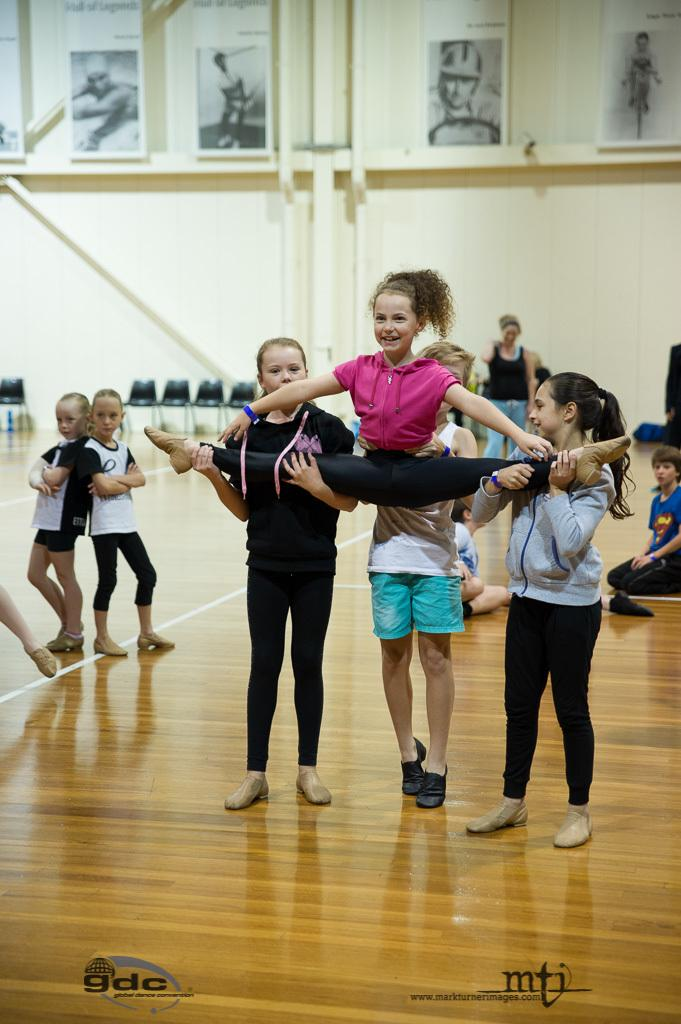What are the people in the image doing? There is a group of people on the floor in the image. What can be seen in the background of the image? There are chairs, a wall, and photo frames in the background of the image. What time of day was the image taken? The image was taken during the day. Where was the image taken? The image was taken on a play court. What type of oatmeal is being served in the image? There is no oatmeal present in the image. What message of peace can be seen in the image? There is no message of peace depicted in the image. 